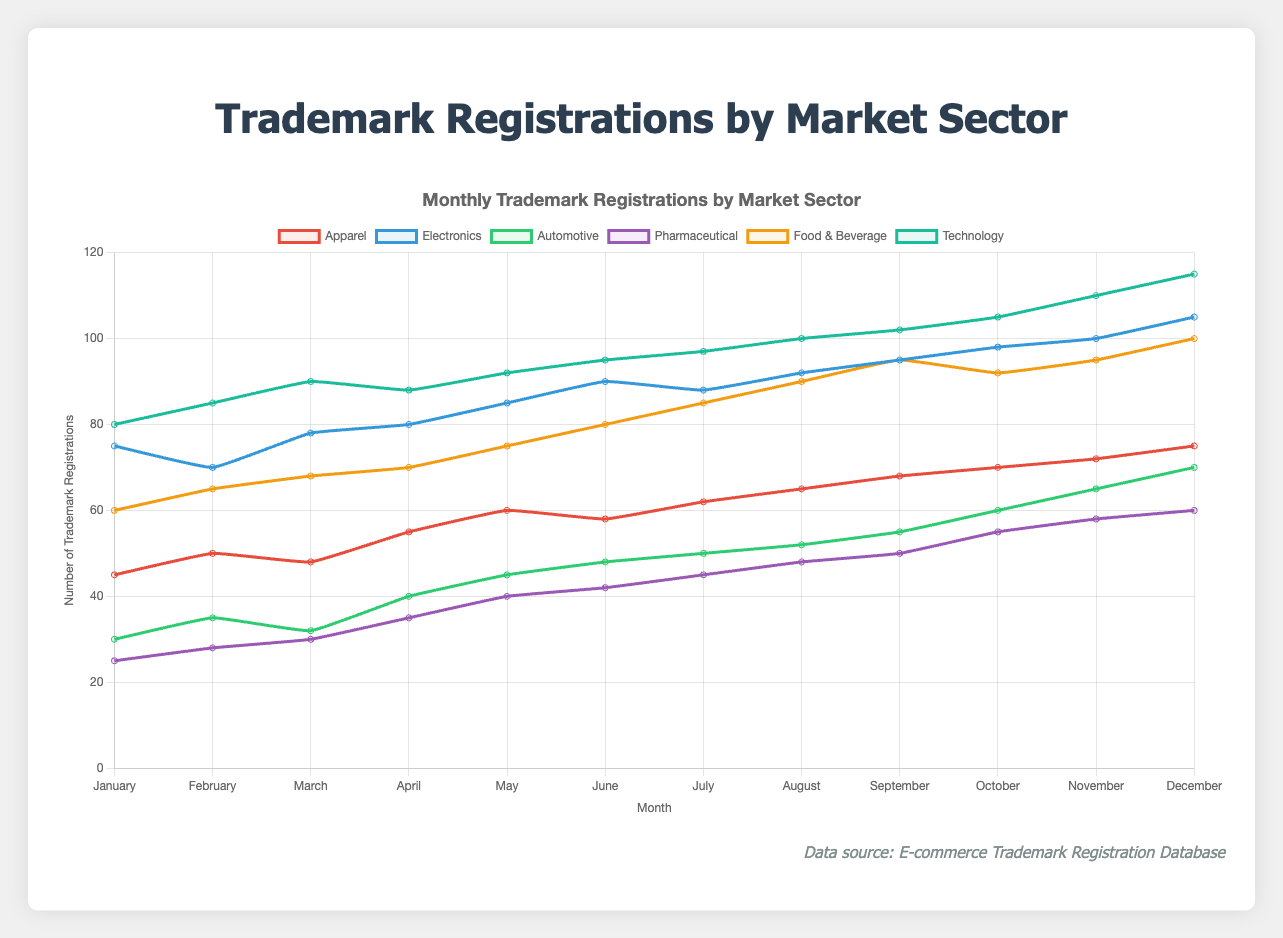What is the total number of trademark registrations in January for all sectors? Summing up the number of registrations in January for all sectors: 45 (Apparel) + 75 (Electronics) + 30 (Automotive) + 25 (Pharmaceutical) + 60 (Food & Beverage) + 80 (Technology) = 315
Answer: 315 Which sector had the highest number of trademark registrations in December? Observing the data for December, the sector with the highest number of registrations is Technology with 115 registrations.
Answer: Technology By how much did the number of trademark registrations in the Food & Beverage sector increase from January to December? The number of registrations in the Food & Beverage sector in January is 60 and in December is 100. The increase is 100 - 60 = 40
Answer: 40 What is the average number of trademark registrations in the Electronics sector over the year? Adding the number of registrations in the Electronics sector for each month and dividing by 12: (75 + 70 + 78 + 80 + 85 + 90 + 88 + 92 + 95 + 98 + 100 + 105)/12 = 920/12 ≈ 76.67
Answer: 76.67 Which two sectors have the closest number of trademark registrations in September? Comparing the numbers in September: Apparel (68), Electronics (95), Automotive (55), Pharmaceutical (50), Food & Beverage (95), Technology (102). Electronics and Food & Beverage both have 95 registrations, which makes them the closest sectors in terms of number of registrations.
Answer: Electronics and Food & Beverage What is the difference in the number of trademark registrations between the Automotive sector and the Pharmaceutical sector in November? The number of registrations in November for the Automotive sector is 65 and for the Pharmaceutical sector is 58. The difference is 65 - 58 = 7
Answer: 7 How many times does the number of trademark registrations in Technology exceed those in Pharmaceutical in May? The number of registrations for Technology in May is 92 and for Pharmaceutical is 40. The ratio is 92 / 40 = 2.3
Answer: 2.3 times Which sector experienced a steady increase in the number of trademark registrations from February to March? Reviewing the data from February to March, the Pharmaceuticals sector increased steadily from 28 to 30 registrations, without any decrease.
Answer: Pharmaceutical In which month did the Automotive sector reach its peak number of trademark registrations? The Automotive sector had its highest number of registrations in December, with 70 registrations.
Answer: December 